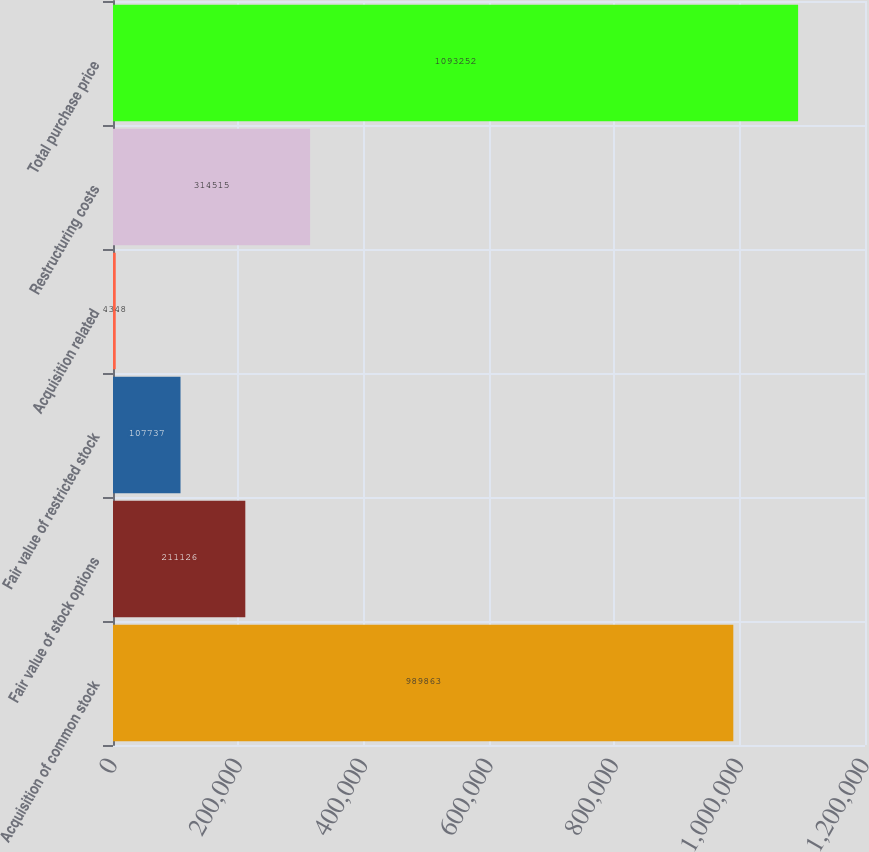Convert chart. <chart><loc_0><loc_0><loc_500><loc_500><bar_chart><fcel>Acquisition of common stock<fcel>Fair value of stock options<fcel>Fair value of restricted stock<fcel>Acquisition related<fcel>Restructuring costs<fcel>Total purchase price<nl><fcel>989863<fcel>211126<fcel>107737<fcel>4348<fcel>314515<fcel>1.09325e+06<nl></chart> 